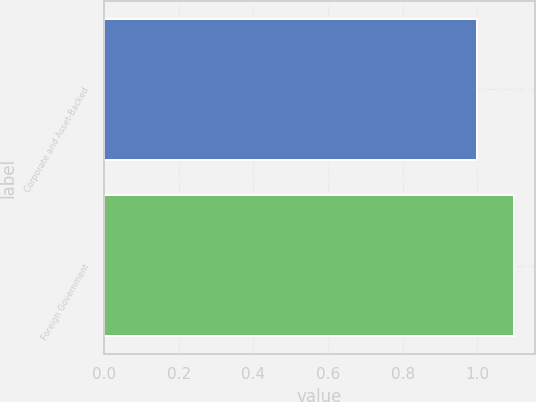Convert chart to OTSL. <chart><loc_0><loc_0><loc_500><loc_500><bar_chart><fcel>Corporate and Asset-Backed<fcel>Foreign Government<nl><fcel>1<fcel>1.1<nl></chart> 